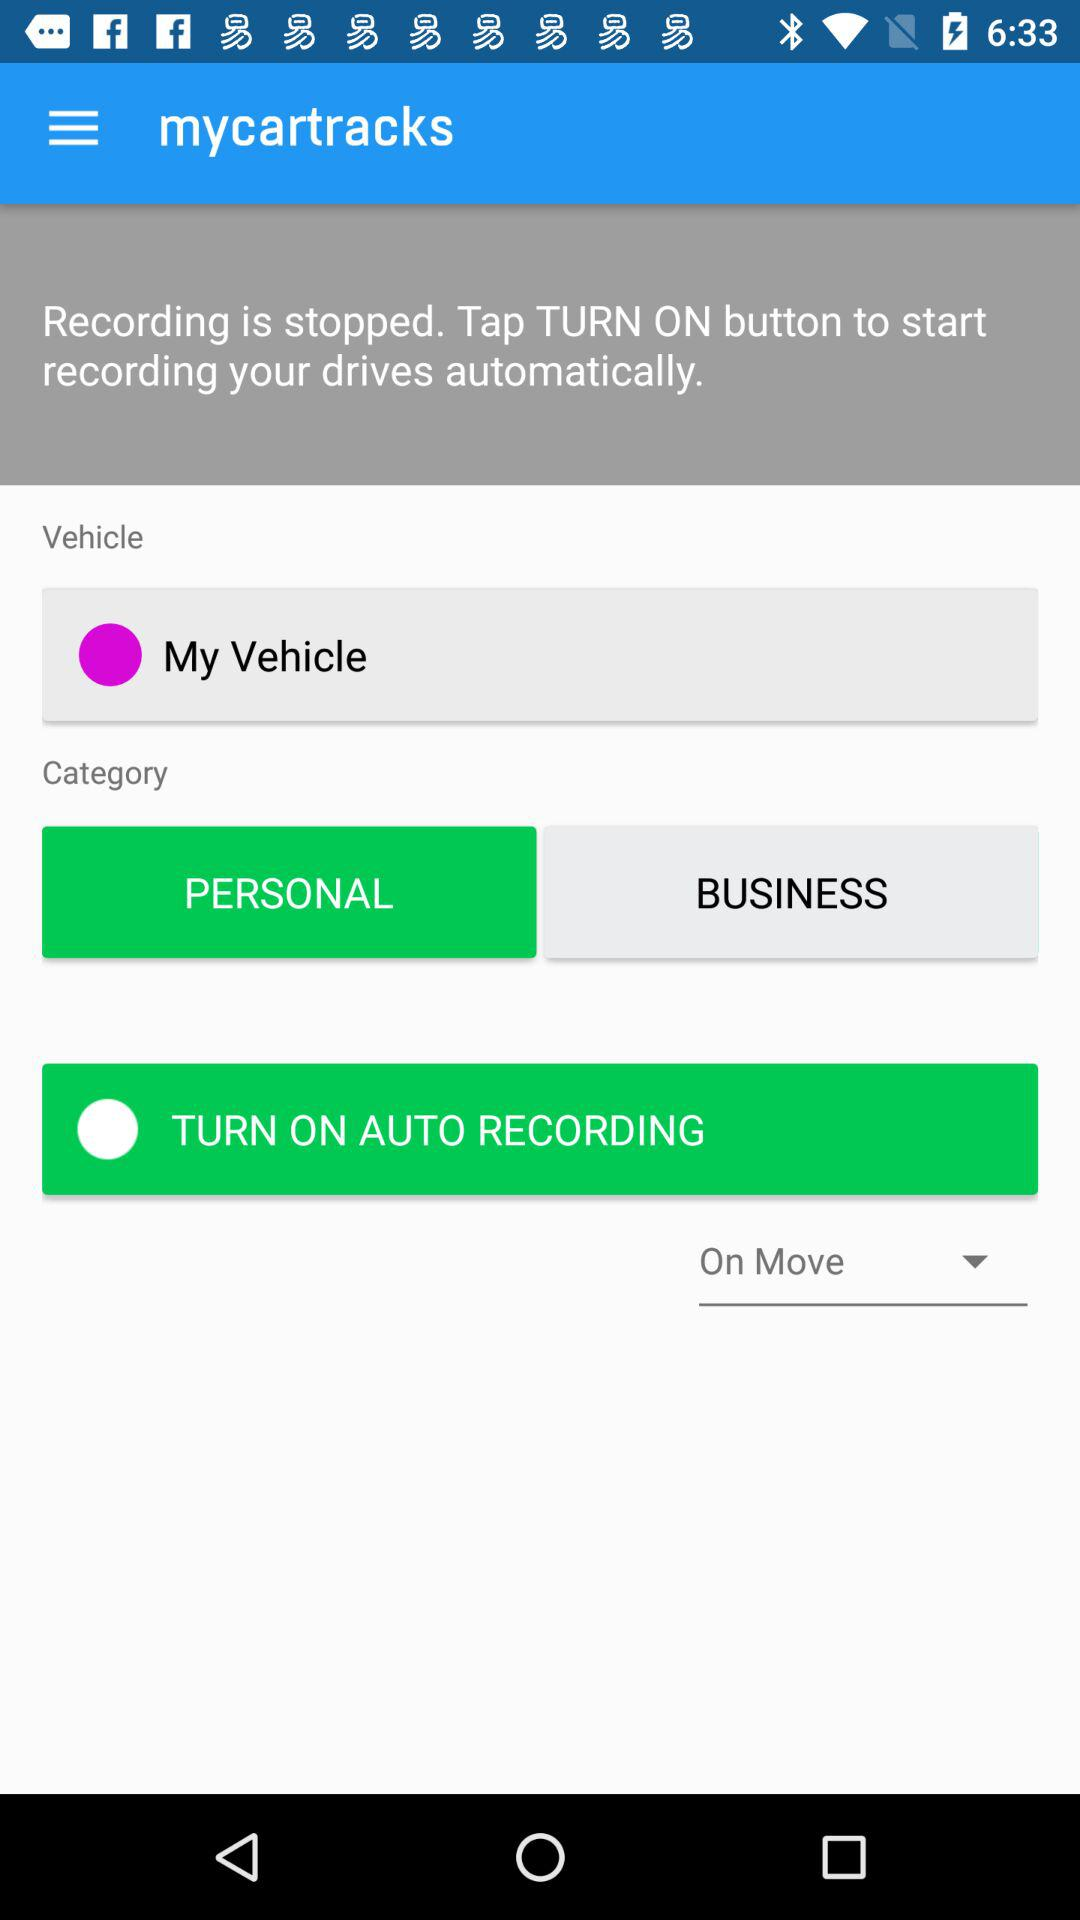What is the category of the vehicle? The category is "PERSONAL". 